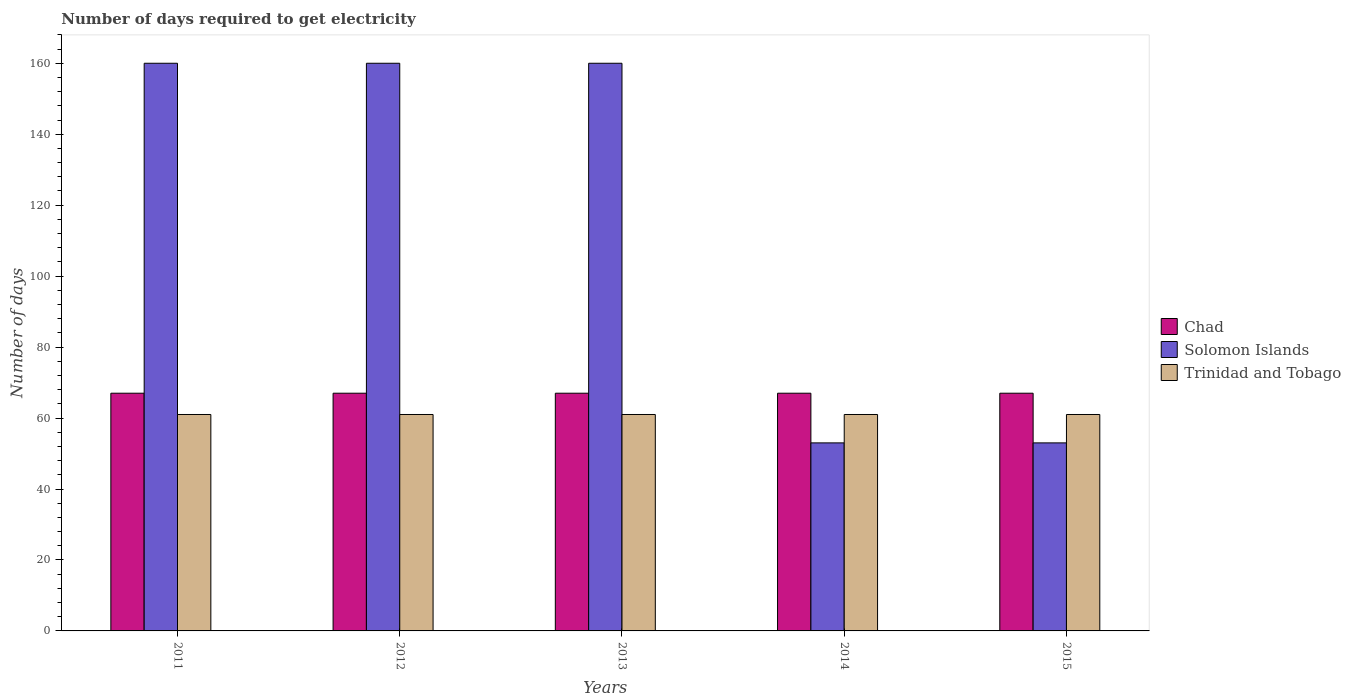How many different coloured bars are there?
Provide a succinct answer. 3. How many groups of bars are there?
Offer a very short reply. 5. Are the number of bars on each tick of the X-axis equal?
Offer a very short reply. Yes. How many bars are there on the 1st tick from the left?
Give a very brief answer. 3. How many bars are there on the 4th tick from the right?
Provide a short and direct response. 3. In how many cases, is the number of bars for a given year not equal to the number of legend labels?
Offer a terse response. 0. What is the number of days required to get electricity in in Trinidad and Tobago in 2014?
Ensure brevity in your answer.  61. Across all years, what is the maximum number of days required to get electricity in in Solomon Islands?
Your answer should be compact. 160. Across all years, what is the minimum number of days required to get electricity in in Trinidad and Tobago?
Your answer should be compact. 61. What is the total number of days required to get electricity in in Chad in the graph?
Your answer should be compact. 335. What is the difference between the number of days required to get electricity in in Solomon Islands in 2013 and that in 2015?
Provide a succinct answer. 107. What is the difference between the number of days required to get electricity in in Trinidad and Tobago in 2011 and the number of days required to get electricity in in Chad in 2015?
Your answer should be very brief. -6. What is the average number of days required to get electricity in in Solomon Islands per year?
Provide a succinct answer. 117.2. In the year 2011, what is the difference between the number of days required to get electricity in in Trinidad and Tobago and number of days required to get electricity in in Solomon Islands?
Provide a short and direct response. -99. In how many years, is the number of days required to get electricity in in Chad greater than the average number of days required to get electricity in in Chad taken over all years?
Provide a short and direct response. 0. What does the 1st bar from the left in 2013 represents?
Offer a very short reply. Chad. What does the 1st bar from the right in 2013 represents?
Your answer should be very brief. Trinidad and Tobago. Is it the case that in every year, the sum of the number of days required to get electricity in in Chad and number of days required to get electricity in in Trinidad and Tobago is greater than the number of days required to get electricity in in Solomon Islands?
Provide a short and direct response. No. How many bars are there?
Your answer should be compact. 15. How many years are there in the graph?
Offer a very short reply. 5. Are the values on the major ticks of Y-axis written in scientific E-notation?
Provide a succinct answer. No. Does the graph contain any zero values?
Make the answer very short. No. Where does the legend appear in the graph?
Offer a terse response. Center right. What is the title of the graph?
Make the answer very short. Number of days required to get electricity. What is the label or title of the X-axis?
Your answer should be compact. Years. What is the label or title of the Y-axis?
Offer a terse response. Number of days. What is the Number of days of Chad in 2011?
Your answer should be very brief. 67. What is the Number of days of Solomon Islands in 2011?
Provide a short and direct response. 160. What is the Number of days of Solomon Islands in 2012?
Make the answer very short. 160. What is the Number of days of Solomon Islands in 2013?
Give a very brief answer. 160. What is the Number of days of Chad in 2014?
Make the answer very short. 67. What is the Number of days in Solomon Islands in 2014?
Your response must be concise. 53. What is the Number of days in Trinidad and Tobago in 2014?
Offer a terse response. 61. What is the Number of days in Chad in 2015?
Offer a terse response. 67. What is the Number of days in Solomon Islands in 2015?
Your answer should be compact. 53. Across all years, what is the maximum Number of days in Chad?
Ensure brevity in your answer.  67. Across all years, what is the maximum Number of days of Solomon Islands?
Make the answer very short. 160. Across all years, what is the maximum Number of days of Trinidad and Tobago?
Your response must be concise. 61. Across all years, what is the minimum Number of days of Chad?
Offer a terse response. 67. What is the total Number of days in Chad in the graph?
Your response must be concise. 335. What is the total Number of days of Solomon Islands in the graph?
Keep it short and to the point. 586. What is the total Number of days of Trinidad and Tobago in the graph?
Ensure brevity in your answer.  305. What is the difference between the Number of days in Chad in 2011 and that in 2012?
Provide a short and direct response. 0. What is the difference between the Number of days in Solomon Islands in 2011 and that in 2013?
Keep it short and to the point. 0. What is the difference between the Number of days in Trinidad and Tobago in 2011 and that in 2013?
Provide a short and direct response. 0. What is the difference between the Number of days of Solomon Islands in 2011 and that in 2014?
Your response must be concise. 107. What is the difference between the Number of days of Trinidad and Tobago in 2011 and that in 2014?
Offer a very short reply. 0. What is the difference between the Number of days in Chad in 2011 and that in 2015?
Give a very brief answer. 0. What is the difference between the Number of days in Solomon Islands in 2011 and that in 2015?
Your answer should be compact. 107. What is the difference between the Number of days of Chad in 2012 and that in 2013?
Give a very brief answer. 0. What is the difference between the Number of days in Solomon Islands in 2012 and that in 2013?
Keep it short and to the point. 0. What is the difference between the Number of days in Trinidad and Tobago in 2012 and that in 2013?
Offer a very short reply. 0. What is the difference between the Number of days of Chad in 2012 and that in 2014?
Provide a succinct answer. 0. What is the difference between the Number of days of Solomon Islands in 2012 and that in 2014?
Provide a succinct answer. 107. What is the difference between the Number of days in Chad in 2012 and that in 2015?
Provide a short and direct response. 0. What is the difference between the Number of days of Solomon Islands in 2012 and that in 2015?
Offer a very short reply. 107. What is the difference between the Number of days of Chad in 2013 and that in 2014?
Offer a very short reply. 0. What is the difference between the Number of days of Solomon Islands in 2013 and that in 2014?
Keep it short and to the point. 107. What is the difference between the Number of days in Trinidad and Tobago in 2013 and that in 2014?
Give a very brief answer. 0. What is the difference between the Number of days in Chad in 2013 and that in 2015?
Offer a terse response. 0. What is the difference between the Number of days in Solomon Islands in 2013 and that in 2015?
Make the answer very short. 107. What is the difference between the Number of days in Trinidad and Tobago in 2013 and that in 2015?
Your answer should be compact. 0. What is the difference between the Number of days in Chad in 2014 and that in 2015?
Offer a terse response. 0. What is the difference between the Number of days in Solomon Islands in 2014 and that in 2015?
Offer a terse response. 0. What is the difference between the Number of days of Chad in 2011 and the Number of days of Solomon Islands in 2012?
Offer a terse response. -93. What is the difference between the Number of days in Chad in 2011 and the Number of days in Trinidad and Tobago in 2012?
Ensure brevity in your answer.  6. What is the difference between the Number of days in Chad in 2011 and the Number of days in Solomon Islands in 2013?
Your response must be concise. -93. What is the difference between the Number of days of Chad in 2011 and the Number of days of Solomon Islands in 2014?
Offer a very short reply. 14. What is the difference between the Number of days of Chad in 2011 and the Number of days of Solomon Islands in 2015?
Provide a short and direct response. 14. What is the difference between the Number of days in Solomon Islands in 2011 and the Number of days in Trinidad and Tobago in 2015?
Provide a succinct answer. 99. What is the difference between the Number of days in Chad in 2012 and the Number of days in Solomon Islands in 2013?
Your answer should be compact. -93. What is the difference between the Number of days in Chad in 2012 and the Number of days in Trinidad and Tobago in 2013?
Offer a terse response. 6. What is the difference between the Number of days in Chad in 2012 and the Number of days in Solomon Islands in 2015?
Provide a succinct answer. 14. What is the difference between the Number of days of Chad in 2012 and the Number of days of Trinidad and Tobago in 2015?
Provide a succinct answer. 6. What is the difference between the Number of days in Solomon Islands in 2012 and the Number of days in Trinidad and Tobago in 2015?
Your answer should be very brief. 99. What is the difference between the Number of days of Chad in 2013 and the Number of days of Trinidad and Tobago in 2014?
Your answer should be very brief. 6. What is the difference between the Number of days of Chad in 2013 and the Number of days of Trinidad and Tobago in 2015?
Give a very brief answer. 6. What is the difference between the Number of days in Chad in 2014 and the Number of days in Trinidad and Tobago in 2015?
Make the answer very short. 6. What is the difference between the Number of days in Solomon Islands in 2014 and the Number of days in Trinidad and Tobago in 2015?
Ensure brevity in your answer.  -8. What is the average Number of days of Chad per year?
Ensure brevity in your answer.  67. What is the average Number of days in Solomon Islands per year?
Provide a succinct answer. 117.2. What is the average Number of days of Trinidad and Tobago per year?
Your answer should be compact. 61. In the year 2011, what is the difference between the Number of days in Chad and Number of days in Solomon Islands?
Make the answer very short. -93. In the year 2011, what is the difference between the Number of days of Chad and Number of days of Trinidad and Tobago?
Give a very brief answer. 6. In the year 2011, what is the difference between the Number of days in Solomon Islands and Number of days in Trinidad and Tobago?
Give a very brief answer. 99. In the year 2012, what is the difference between the Number of days of Chad and Number of days of Solomon Islands?
Your answer should be compact. -93. In the year 2013, what is the difference between the Number of days of Chad and Number of days of Solomon Islands?
Your response must be concise. -93. In the year 2013, what is the difference between the Number of days in Chad and Number of days in Trinidad and Tobago?
Ensure brevity in your answer.  6. In the year 2013, what is the difference between the Number of days in Solomon Islands and Number of days in Trinidad and Tobago?
Offer a terse response. 99. In the year 2015, what is the difference between the Number of days of Chad and Number of days of Solomon Islands?
Offer a very short reply. 14. What is the ratio of the Number of days of Chad in 2011 to that in 2012?
Ensure brevity in your answer.  1. What is the ratio of the Number of days of Trinidad and Tobago in 2011 to that in 2012?
Provide a succinct answer. 1. What is the ratio of the Number of days of Solomon Islands in 2011 to that in 2013?
Give a very brief answer. 1. What is the ratio of the Number of days of Trinidad and Tobago in 2011 to that in 2013?
Your answer should be compact. 1. What is the ratio of the Number of days of Solomon Islands in 2011 to that in 2014?
Offer a very short reply. 3.02. What is the ratio of the Number of days in Solomon Islands in 2011 to that in 2015?
Offer a terse response. 3.02. What is the ratio of the Number of days of Trinidad and Tobago in 2011 to that in 2015?
Provide a short and direct response. 1. What is the ratio of the Number of days of Chad in 2012 to that in 2013?
Make the answer very short. 1. What is the ratio of the Number of days in Solomon Islands in 2012 to that in 2013?
Your response must be concise. 1. What is the ratio of the Number of days in Trinidad and Tobago in 2012 to that in 2013?
Provide a succinct answer. 1. What is the ratio of the Number of days of Solomon Islands in 2012 to that in 2014?
Keep it short and to the point. 3.02. What is the ratio of the Number of days in Trinidad and Tobago in 2012 to that in 2014?
Make the answer very short. 1. What is the ratio of the Number of days of Solomon Islands in 2012 to that in 2015?
Provide a short and direct response. 3.02. What is the ratio of the Number of days in Trinidad and Tobago in 2012 to that in 2015?
Provide a succinct answer. 1. What is the ratio of the Number of days of Chad in 2013 to that in 2014?
Offer a terse response. 1. What is the ratio of the Number of days in Solomon Islands in 2013 to that in 2014?
Offer a terse response. 3.02. What is the ratio of the Number of days of Trinidad and Tobago in 2013 to that in 2014?
Provide a short and direct response. 1. What is the ratio of the Number of days in Solomon Islands in 2013 to that in 2015?
Ensure brevity in your answer.  3.02. What is the ratio of the Number of days of Solomon Islands in 2014 to that in 2015?
Your answer should be very brief. 1. What is the ratio of the Number of days of Trinidad and Tobago in 2014 to that in 2015?
Keep it short and to the point. 1. What is the difference between the highest and the second highest Number of days in Chad?
Offer a very short reply. 0. What is the difference between the highest and the second highest Number of days in Solomon Islands?
Provide a succinct answer. 0. What is the difference between the highest and the second highest Number of days of Trinidad and Tobago?
Give a very brief answer. 0. What is the difference between the highest and the lowest Number of days of Chad?
Make the answer very short. 0. What is the difference between the highest and the lowest Number of days of Solomon Islands?
Offer a terse response. 107. 